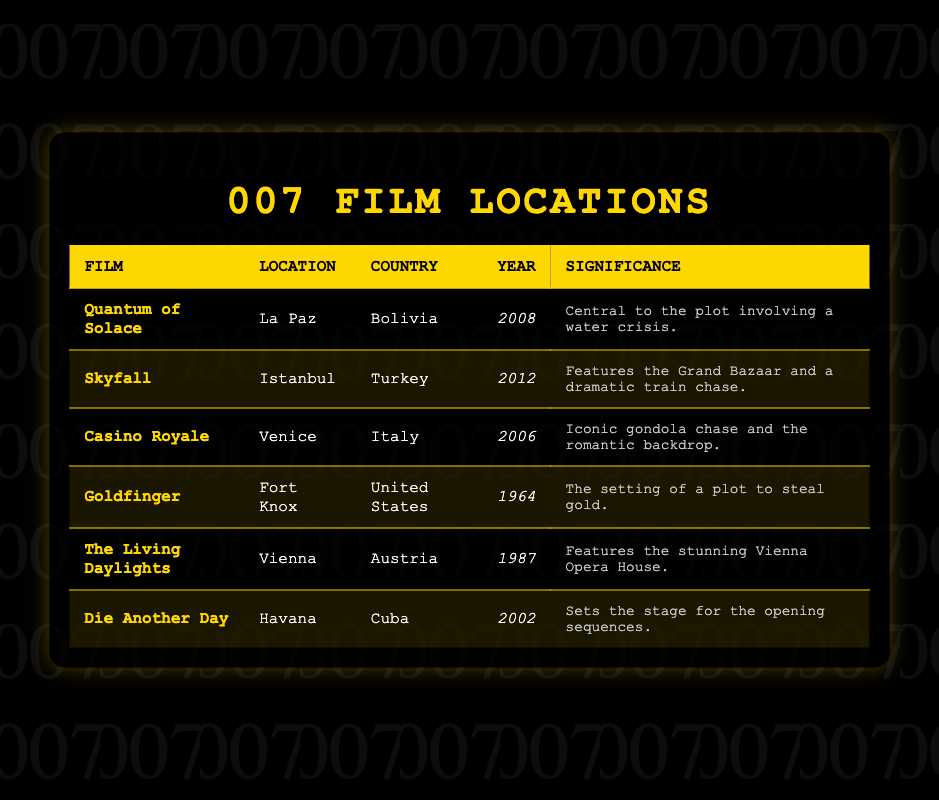What is the filming location for "Quantum of Solace"? The row for "Quantum of Solace" shows "La Paz" as the location.
Answer: La Paz Which film was set in Italy? In the table, "Casino Royale" is the film listed with "Venice" as its location, which is in Italy.
Answer: Casino Royale How many Bond films were filmed in the 2000s? The films from the 2000s in the table are "Casino Royale" (2006), "Die Another Day" (2002), and "Quantum of Solace" (2008), totaling three films.
Answer: 3 Did "Goldfinger" feature a location outside of the United States? According to the data, "Goldfinger" is set in Fort Knox, which is in the United States, so the statement is false.
Answer: No Which country hosted the most recent Bond film location listed in the table? The most recent film is "Skyfall" (2012), which is filmed in Turkey, making it the most recent location.
Answer: Turkey What is the average year of the Bond films listed? The years are 2008, 2012, 2006, 1964, 1987, and 2002. The sum of these years is 2008 + 2012 + 2006 + 1964 + 1987 + 2002 = 12079. There are 6 films, so the average year is 12079 / 6 = 2013.17, which rounds to 2013.
Answer: 2013 Which film's location is associated with a water crisis? Referring to the significance column, "Quantum of Solace" is noted as involving a water crisis, linking it to La Paz, Bolivia.
Answer: Quantum of Solace Is the Vienna Opera House featured in "Die Another Day"? The table states that "The Living Daylights" features the Vienna Opera House, not "Die Another Day", making the statement false.
Answer: No Which film has the setting of a gold theft plot? "Goldfinger" is noted as the film where there is a plot to steal gold, confirming its connection to Fort Knox.
Answer: Goldfinger 